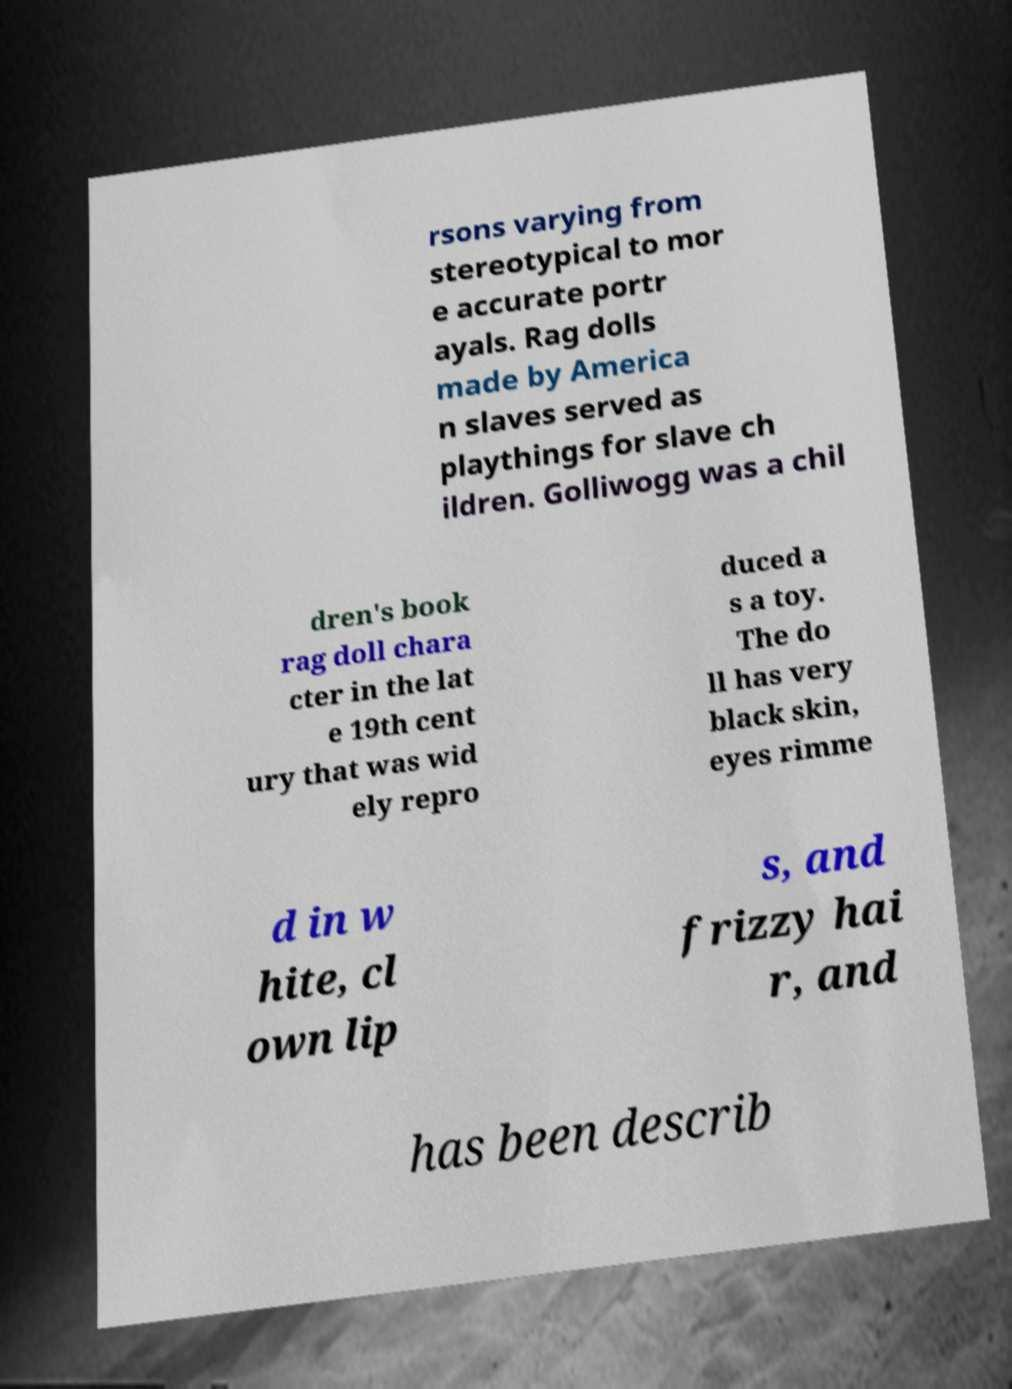Could you assist in decoding the text presented in this image and type it out clearly? rsons varying from stereotypical to mor e accurate portr ayals. Rag dolls made by America n slaves served as playthings for slave ch ildren. Golliwogg was a chil dren's book rag doll chara cter in the lat e 19th cent ury that was wid ely repro duced a s a toy. The do ll has very black skin, eyes rimme d in w hite, cl own lip s, and frizzy hai r, and has been describ 